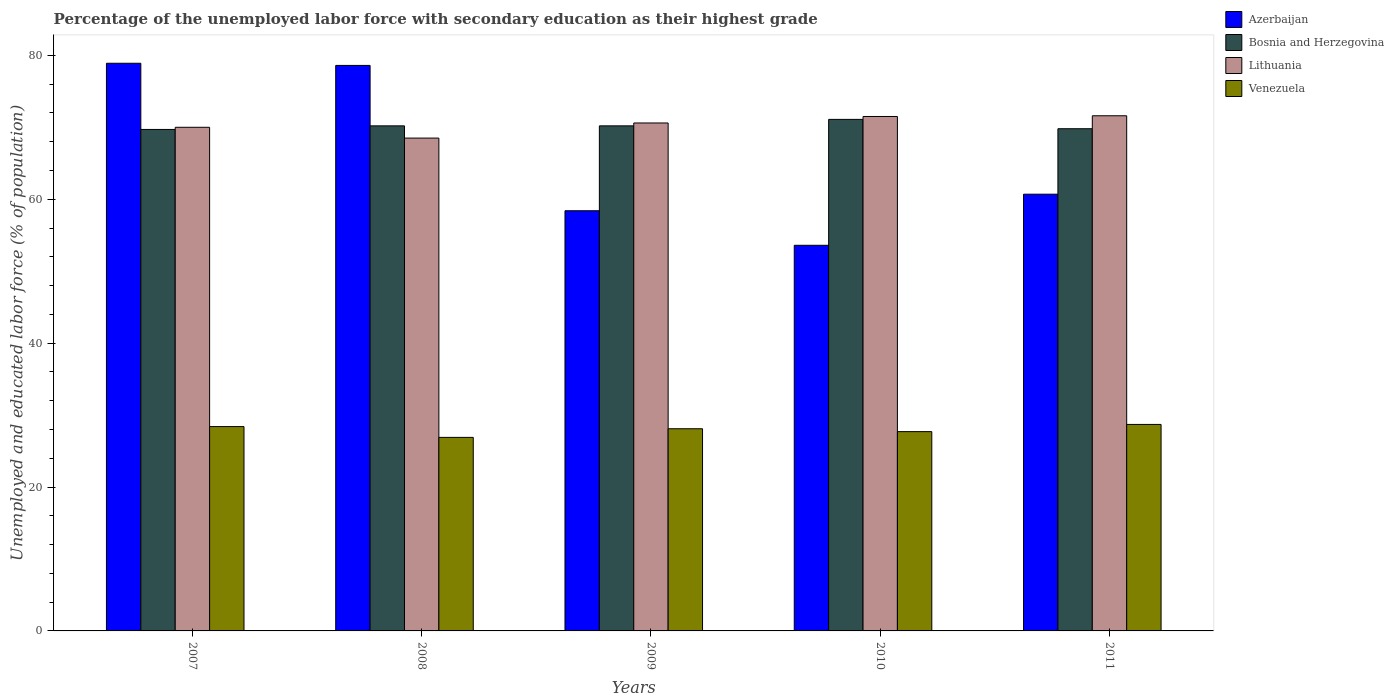How many groups of bars are there?
Provide a short and direct response. 5. Are the number of bars on each tick of the X-axis equal?
Ensure brevity in your answer.  Yes. How many bars are there on the 1st tick from the left?
Your answer should be compact. 4. How many bars are there on the 3rd tick from the right?
Your answer should be compact. 4. What is the label of the 3rd group of bars from the left?
Ensure brevity in your answer.  2009. What is the percentage of the unemployed labor force with secondary education in Azerbaijan in 2007?
Your answer should be very brief. 78.9. Across all years, what is the maximum percentage of the unemployed labor force with secondary education in Azerbaijan?
Provide a short and direct response. 78.9. Across all years, what is the minimum percentage of the unemployed labor force with secondary education in Azerbaijan?
Make the answer very short. 53.6. In which year was the percentage of the unemployed labor force with secondary education in Venezuela maximum?
Offer a terse response. 2011. In which year was the percentage of the unemployed labor force with secondary education in Azerbaijan minimum?
Offer a terse response. 2010. What is the total percentage of the unemployed labor force with secondary education in Azerbaijan in the graph?
Make the answer very short. 330.2. What is the difference between the percentage of the unemployed labor force with secondary education in Lithuania in 2010 and that in 2011?
Give a very brief answer. -0.1. What is the difference between the percentage of the unemployed labor force with secondary education in Lithuania in 2011 and the percentage of the unemployed labor force with secondary education in Venezuela in 2008?
Give a very brief answer. 44.7. What is the average percentage of the unemployed labor force with secondary education in Azerbaijan per year?
Your answer should be very brief. 66.04. In the year 2007, what is the difference between the percentage of the unemployed labor force with secondary education in Azerbaijan and percentage of the unemployed labor force with secondary education in Lithuania?
Your answer should be compact. 8.9. What is the ratio of the percentage of the unemployed labor force with secondary education in Azerbaijan in 2007 to that in 2011?
Provide a short and direct response. 1.3. Is the difference between the percentage of the unemployed labor force with secondary education in Azerbaijan in 2007 and 2010 greater than the difference between the percentage of the unemployed labor force with secondary education in Lithuania in 2007 and 2010?
Your answer should be very brief. Yes. What is the difference between the highest and the second highest percentage of the unemployed labor force with secondary education in Venezuela?
Offer a terse response. 0.3. What is the difference between the highest and the lowest percentage of the unemployed labor force with secondary education in Bosnia and Herzegovina?
Provide a short and direct response. 1.4. Is it the case that in every year, the sum of the percentage of the unemployed labor force with secondary education in Lithuania and percentage of the unemployed labor force with secondary education in Bosnia and Herzegovina is greater than the sum of percentage of the unemployed labor force with secondary education in Venezuela and percentage of the unemployed labor force with secondary education in Azerbaijan?
Give a very brief answer. No. What does the 4th bar from the left in 2010 represents?
Your answer should be compact. Venezuela. What does the 2nd bar from the right in 2009 represents?
Your answer should be very brief. Lithuania. Is it the case that in every year, the sum of the percentage of the unemployed labor force with secondary education in Bosnia and Herzegovina and percentage of the unemployed labor force with secondary education in Lithuania is greater than the percentage of the unemployed labor force with secondary education in Venezuela?
Give a very brief answer. Yes. Are the values on the major ticks of Y-axis written in scientific E-notation?
Your answer should be very brief. No. Does the graph contain any zero values?
Provide a succinct answer. No. Does the graph contain grids?
Your response must be concise. No. How many legend labels are there?
Your answer should be very brief. 4. How are the legend labels stacked?
Give a very brief answer. Vertical. What is the title of the graph?
Provide a short and direct response. Percentage of the unemployed labor force with secondary education as their highest grade. What is the label or title of the Y-axis?
Make the answer very short. Unemployed and educated labor force (% of population). What is the Unemployed and educated labor force (% of population) of Azerbaijan in 2007?
Your answer should be very brief. 78.9. What is the Unemployed and educated labor force (% of population) in Bosnia and Herzegovina in 2007?
Keep it short and to the point. 69.7. What is the Unemployed and educated labor force (% of population) in Venezuela in 2007?
Your response must be concise. 28.4. What is the Unemployed and educated labor force (% of population) of Azerbaijan in 2008?
Ensure brevity in your answer.  78.6. What is the Unemployed and educated labor force (% of population) of Bosnia and Herzegovina in 2008?
Your response must be concise. 70.2. What is the Unemployed and educated labor force (% of population) in Lithuania in 2008?
Your response must be concise. 68.5. What is the Unemployed and educated labor force (% of population) of Venezuela in 2008?
Ensure brevity in your answer.  26.9. What is the Unemployed and educated labor force (% of population) of Azerbaijan in 2009?
Offer a terse response. 58.4. What is the Unemployed and educated labor force (% of population) of Bosnia and Herzegovina in 2009?
Your answer should be compact. 70.2. What is the Unemployed and educated labor force (% of population) in Lithuania in 2009?
Make the answer very short. 70.6. What is the Unemployed and educated labor force (% of population) of Venezuela in 2009?
Make the answer very short. 28.1. What is the Unemployed and educated labor force (% of population) of Azerbaijan in 2010?
Provide a short and direct response. 53.6. What is the Unemployed and educated labor force (% of population) in Bosnia and Herzegovina in 2010?
Provide a succinct answer. 71.1. What is the Unemployed and educated labor force (% of population) of Lithuania in 2010?
Provide a succinct answer. 71.5. What is the Unemployed and educated labor force (% of population) of Venezuela in 2010?
Provide a succinct answer. 27.7. What is the Unemployed and educated labor force (% of population) of Azerbaijan in 2011?
Offer a very short reply. 60.7. What is the Unemployed and educated labor force (% of population) in Bosnia and Herzegovina in 2011?
Offer a terse response. 69.8. What is the Unemployed and educated labor force (% of population) in Lithuania in 2011?
Your response must be concise. 71.6. What is the Unemployed and educated labor force (% of population) in Venezuela in 2011?
Provide a succinct answer. 28.7. Across all years, what is the maximum Unemployed and educated labor force (% of population) in Azerbaijan?
Offer a very short reply. 78.9. Across all years, what is the maximum Unemployed and educated labor force (% of population) in Bosnia and Herzegovina?
Offer a terse response. 71.1. Across all years, what is the maximum Unemployed and educated labor force (% of population) of Lithuania?
Ensure brevity in your answer.  71.6. Across all years, what is the maximum Unemployed and educated labor force (% of population) in Venezuela?
Your response must be concise. 28.7. Across all years, what is the minimum Unemployed and educated labor force (% of population) of Azerbaijan?
Keep it short and to the point. 53.6. Across all years, what is the minimum Unemployed and educated labor force (% of population) of Bosnia and Herzegovina?
Your answer should be compact. 69.7. Across all years, what is the minimum Unemployed and educated labor force (% of population) in Lithuania?
Offer a very short reply. 68.5. Across all years, what is the minimum Unemployed and educated labor force (% of population) of Venezuela?
Your answer should be very brief. 26.9. What is the total Unemployed and educated labor force (% of population) in Azerbaijan in the graph?
Keep it short and to the point. 330.2. What is the total Unemployed and educated labor force (% of population) in Bosnia and Herzegovina in the graph?
Keep it short and to the point. 351. What is the total Unemployed and educated labor force (% of population) of Lithuania in the graph?
Ensure brevity in your answer.  352.2. What is the total Unemployed and educated labor force (% of population) of Venezuela in the graph?
Keep it short and to the point. 139.8. What is the difference between the Unemployed and educated labor force (% of population) of Azerbaijan in 2007 and that in 2008?
Give a very brief answer. 0.3. What is the difference between the Unemployed and educated labor force (% of population) of Lithuania in 2007 and that in 2008?
Give a very brief answer. 1.5. What is the difference between the Unemployed and educated labor force (% of population) of Lithuania in 2007 and that in 2009?
Provide a short and direct response. -0.6. What is the difference between the Unemployed and educated labor force (% of population) of Azerbaijan in 2007 and that in 2010?
Your answer should be very brief. 25.3. What is the difference between the Unemployed and educated labor force (% of population) in Lithuania in 2007 and that in 2010?
Offer a terse response. -1.5. What is the difference between the Unemployed and educated labor force (% of population) in Venezuela in 2007 and that in 2010?
Offer a terse response. 0.7. What is the difference between the Unemployed and educated labor force (% of population) of Azerbaijan in 2007 and that in 2011?
Make the answer very short. 18.2. What is the difference between the Unemployed and educated labor force (% of population) in Bosnia and Herzegovina in 2007 and that in 2011?
Give a very brief answer. -0.1. What is the difference between the Unemployed and educated labor force (% of population) of Lithuania in 2007 and that in 2011?
Provide a short and direct response. -1.6. What is the difference between the Unemployed and educated labor force (% of population) of Venezuela in 2007 and that in 2011?
Keep it short and to the point. -0.3. What is the difference between the Unemployed and educated labor force (% of population) in Azerbaijan in 2008 and that in 2009?
Your answer should be compact. 20.2. What is the difference between the Unemployed and educated labor force (% of population) in Venezuela in 2008 and that in 2009?
Make the answer very short. -1.2. What is the difference between the Unemployed and educated labor force (% of population) in Bosnia and Herzegovina in 2008 and that in 2010?
Provide a short and direct response. -0.9. What is the difference between the Unemployed and educated labor force (% of population) of Bosnia and Herzegovina in 2008 and that in 2011?
Keep it short and to the point. 0.4. What is the difference between the Unemployed and educated labor force (% of population) in Lithuania in 2008 and that in 2011?
Keep it short and to the point. -3.1. What is the difference between the Unemployed and educated labor force (% of population) of Venezuela in 2008 and that in 2011?
Ensure brevity in your answer.  -1.8. What is the difference between the Unemployed and educated labor force (% of population) of Azerbaijan in 2009 and that in 2010?
Offer a terse response. 4.8. What is the difference between the Unemployed and educated labor force (% of population) in Bosnia and Herzegovina in 2009 and that in 2010?
Offer a very short reply. -0.9. What is the difference between the Unemployed and educated labor force (% of population) in Venezuela in 2009 and that in 2010?
Ensure brevity in your answer.  0.4. What is the difference between the Unemployed and educated labor force (% of population) in Lithuania in 2009 and that in 2011?
Your answer should be compact. -1. What is the difference between the Unemployed and educated labor force (% of population) in Venezuela in 2009 and that in 2011?
Your response must be concise. -0.6. What is the difference between the Unemployed and educated labor force (% of population) of Azerbaijan in 2007 and the Unemployed and educated labor force (% of population) of Venezuela in 2008?
Your answer should be compact. 52. What is the difference between the Unemployed and educated labor force (% of population) in Bosnia and Herzegovina in 2007 and the Unemployed and educated labor force (% of population) in Lithuania in 2008?
Your answer should be very brief. 1.2. What is the difference between the Unemployed and educated labor force (% of population) in Bosnia and Herzegovina in 2007 and the Unemployed and educated labor force (% of population) in Venezuela in 2008?
Your answer should be compact. 42.8. What is the difference between the Unemployed and educated labor force (% of population) of Lithuania in 2007 and the Unemployed and educated labor force (% of population) of Venezuela in 2008?
Offer a very short reply. 43.1. What is the difference between the Unemployed and educated labor force (% of population) of Azerbaijan in 2007 and the Unemployed and educated labor force (% of population) of Venezuela in 2009?
Your answer should be very brief. 50.8. What is the difference between the Unemployed and educated labor force (% of population) in Bosnia and Herzegovina in 2007 and the Unemployed and educated labor force (% of population) in Venezuela in 2009?
Provide a succinct answer. 41.6. What is the difference between the Unemployed and educated labor force (% of population) of Lithuania in 2007 and the Unemployed and educated labor force (% of population) of Venezuela in 2009?
Your answer should be very brief. 41.9. What is the difference between the Unemployed and educated labor force (% of population) in Azerbaijan in 2007 and the Unemployed and educated labor force (% of population) in Bosnia and Herzegovina in 2010?
Make the answer very short. 7.8. What is the difference between the Unemployed and educated labor force (% of population) of Azerbaijan in 2007 and the Unemployed and educated labor force (% of population) of Lithuania in 2010?
Give a very brief answer. 7.4. What is the difference between the Unemployed and educated labor force (% of population) in Azerbaijan in 2007 and the Unemployed and educated labor force (% of population) in Venezuela in 2010?
Offer a terse response. 51.2. What is the difference between the Unemployed and educated labor force (% of population) of Bosnia and Herzegovina in 2007 and the Unemployed and educated labor force (% of population) of Venezuela in 2010?
Your answer should be very brief. 42. What is the difference between the Unemployed and educated labor force (% of population) in Lithuania in 2007 and the Unemployed and educated labor force (% of population) in Venezuela in 2010?
Make the answer very short. 42.3. What is the difference between the Unemployed and educated labor force (% of population) of Azerbaijan in 2007 and the Unemployed and educated labor force (% of population) of Bosnia and Herzegovina in 2011?
Offer a very short reply. 9.1. What is the difference between the Unemployed and educated labor force (% of population) in Azerbaijan in 2007 and the Unemployed and educated labor force (% of population) in Venezuela in 2011?
Offer a terse response. 50.2. What is the difference between the Unemployed and educated labor force (% of population) in Lithuania in 2007 and the Unemployed and educated labor force (% of population) in Venezuela in 2011?
Give a very brief answer. 41.3. What is the difference between the Unemployed and educated labor force (% of population) in Azerbaijan in 2008 and the Unemployed and educated labor force (% of population) in Venezuela in 2009?
Provide a succinct answer. 50.5. What is the difference between the Unemployed and educated labor force (% of population) in Bosnia and Herzegovina in 2008 and the Unemployed and educated labor force (% of population) in Venezuela in 2009?
Offer a very short reply. 42.1. What is the difference between the Unemployed and educated labor force (% of population) in Lithuania in 2008 and the Unemployed and educated labor force (% of population) in Venezuela in 2009?
Your response must be concise. 40.4. What is the difference between the Unemployed and educated labor force (% of population) of Azerbaijan in 2008 and the Unemployed and educated labor force (% of population) of Lithuania in 2010?
Offer a very short reply. 7.1. What is the difference between the Unemployed and educated labor force (% of population) of Azerbaijan in 2008 and the Unemployed and educated labor force (% of population) of Venezuela in 2010?
Ensure brevity in your answer.  50.9. What is the difference between the Unemployed and educated labor force (% of population) in Bosnia and Herzegovina in 2008 and the Unemployed and educated labor force (% of population) in Venezuela in 2010?
Give a very brief answer. 42.5. What is the difference between the Unemployed and educated labor force (% of population) in Lithuania in 2008 and the Unemployed and educated labor force (% of population) in Venezuela in 2010?
Make the answer very short. 40.8. What is the difference between the Unemployed and educated labor force (% of population) in Azerbaijan in 2008 and the Unemployed and educated labor force (% of population) in Venezuela in 2011?
Provide a short and direct response. 49.9. What is the difference between the Unemployed and educated labor force (% of population) of Bosnia and Herzegovina in 2008 and the Unemployed and educated labor force (% of population) of Venezuela in 2011?
Offer a terse response. 41.5. What is the difference between the Unemployed and educated labor force (% of population) in Lithuania in 2008 and the Unemployed and educated labor force (% of population) in Venezuela in 2011?
Make the answer very short. 39.8. What is the difference between the Unemployed and educated labor force (% of population) in Azerbaijan in 2009 and the Unemployed and educated labor force (% of population) in Bosnia and Herzegovina in 2010?
Your answer should be compact. -12.7. What is the difference between the Unemployed and educated labor force (% of population) in Azerbaijan in 2009 and the Unemployed and educated labor force (% of population) in Lithuania in 2010?
Offer a terse response. -13.1. What is the difference between the Unemployed and educated labor force (% of population) in Azerbaijan in 2009 and the Unemployed and educated labor force (% of population) in Venezuela in 2010?
Your answer should be compact. 30.7. What is the difference between the Unemployed and educated labor force (% of population) in Bosnia and Herzegovina in 2009 and the Unemployed and educated labor force (% of population) in Lithuania in 2010?
Make the answer very short. -1.3. What is the difference between the Unemployed and educated labor force (% of population) in Bosnia and Herzegovina in 2009 and the Unemployed and educated labor force (% of population) in Venezuela in 2010?
Your answer should be very brief. 42.5. What is the difference between the Unemployed and educated labor force (% of population) of Lithuania in 2009 and the Unemployed and educated labor force (% of population) of Venezuela in 2010?
Your answer should be compact. 42.9. What is the difference between the Unemployed and educated labor force (% of population) in Azerbaijan in 2009 and the Unemployed and educated labor force (% of population) in Bosnia and Herzegovina in 2011?
Your answer should be very brief. -11.4. What is the difference between the Unemployed and educated labor force (% of population) in Azerbaijan in 2009 and the Unemployed and educated labor force (% of population) in Venezuela in 2011?
Offer a very short reply. 29.7. What is the difference between the Unemployed and educated labor force (% of population) of Bosnia and Herzegovina in 2009 and the Unemployed and educated labor force (% of population) of Venezuela in 2011?
Provide a succinct answer. 41.5. What is the difference between the Unemployed and educated labor force (% of population) of Lithuania in 2009 and the Unemployed and educated labor force (% of population) of Venezuela in 2011?
Your answer should be very brief. 41.9. What is the difference between the Unemployed and educated labor force (% of population) of Azerbaijan in 2010 and the Unemployed and educated labor force (% of population) of Bosnia and Herzegovina in 2011?
Ensure brevity in your answer.  -16.2. What is the difference between the Unemployed and educated labor force (% of population) in Azerbaijan in 2010 and the Unemployed and educated labor force (% of population) in Venezuela in 2011?
Offer a very short reply. 24.9. What is the difference between the Unemployed and educated labor force (% of population) of Bosnia and Herzegovina in 2010 and the Unemployed and educated labor force (% of population) of Venezuela in 2011?
Your answer should be very brief. 42.4. What is the difference between the Unemployed and educated labor force (% of population) of Lithuania in 2010 and the Unemployed and educated labor force (% of population) of Venezuela in 2011?
Give a very brief answer. 42.8. What is the average Unemployed and educated labor force (% of population) of Azerbaijan per year?
Your answer should be compact. 66.04. What is the average Unemployed and educated labor force (% of population) in Bosnia and Herzegovina per year?
Provide a succinct answer. 70.2. What is the average Unemployed and educated labor force (% of population) in Lithuania per year?
Ensure brevity in your answer.  70.44. What is the average Unemployed and educated labor force (% of population) in Venezuela per year?
Offer a very short reply. 27.96. In the year 2007, what is the difference between the Unemployed and educated labor force (% of population) of Azerbaijan and Unemployed and educated labor force (% of population) of Bosnia and Herzegovina?
Make the answer very short. 9.2. In the year 2007, what is the difference between the Unemployed and educated labor force (% of population) of Azerbaijan and Unemployed and educated labor force (% of population) of Lithuania?
Your answer should be very brief. 8.9. In the year 2007, what is the difference between the Unemployed and educated labor force (% of population) of Azerbaijan and Unemployed and educated labor force (% of population) of Venezuela?
Ensure brevity in your answer.  50.5. In the year 2007, what is the difference between the Unemployed and educated labor force (% of population) in Bosnia and Herzegovina and Unemployed and educated labor force (% of population) in Lithuania?
Provide a succinct answer. -0.3. In the year 2007, what is the difference between the Unemployed and educated labor force (% of population) in Bosnia and Herzegovina and Unemployed and educated labor force (% of population) in Venezuela?
Make the answer very short. 41.3. In the year 2007, what is the difference between the Unemployed and educated labor force (% of population) of Lithuania and Unemployed and educated labor force (% of population) of Venezuela?
Offer a terse response. 41.6. In the year 2008, what is the difference between the Unemployed and educated labor force (% of population) in Azerbaijan and Unemployed and educated labor force (% of population) in Bosnia and Herzegovina?
Offer a very short reply. 8.4. In the year 2008, what is the difference between the Unemployed and educated labor force (% of population) of Azerbaijan and Unemployed and educated labor force (% of population) of Venezuela?
Keep it short and to the point. 51.7. In the year 2008, what is the difference between the Unemployed and educated labor force (% of population) in Bosnia and Herzegovina and Unemployed and educated labor force (% of population) in Venezuela?
Your response must be concise. 43.3. In the year 2008, what is the difference between the Unemployed and educated labor force (% of population) of Lithuania and Unemployed and educated labor force (% of population) of Venezuela?
Your answer should be very brief. 41.6. In the year 2009, what is the difference between the Unemployed and educated labor force (% of population) of Azerbaijan and Unemployed and educated labor force (% of population) of Venezuela?
Provide a succinct answer. 30.3. In the year 2009, what is the difference between the Unemployed and educated labor force (% of population) in Bosnia and Herzegovina and Unemployed and educated labor force (% of population) in Venezuela?
Offer a very short reply. 42.1. In the year 2009, what is the difference between the Unemployed and educated labor force (% of population) of Lithuania and Unemployed and educated labor force (% of population) of Venezuela?
Keep it short and to the point. 42.5. In the year 2010, what is the difference between the Unemployed and educated labor force (% of population) in Azerbaijan and Unemployed and educated labor force (% of population) in Bosnia and Herzegovina?
Provide a short and direct response. -17.5. In the year 2010, what is the difference between the Unemployed and educated labor force (% of population) of Azerbaijan and Unemployed and educated labor force (% of population) of Lithuania?
Offer a very short reply. -17.9. In the year 2010, what is the difference between the Unemployed and educated labor force (% of population) of Azerbaijan and Unemployed and educated labor force (% of population) of Venezuela?
Your response must be concise. 25.9. In the year 2010, what is the difference between the Unemployed and educated labor force (% of population) of Bosnia and Herzegovina and Unemployed and educated labor force (% of population) of Venezuela?
Make the answer very short. 43.4. In the year 2010, what is the difference between the Unemployed and educated labor force (% of population) in Lithuania and Unemployed and educated labor force (% of population) in Venezuela?
Your response must be concise. 43.8. In the year 2011, what is the difference between the Unemployed and educated labor force (% of population) of Azerbaijan and Unemployed and educated labor force (% of population) of Bosnia and Herzegovina?
Keep it short and to the point. -9.1. In the year 2011, what is the difference between the Unemployed and educated labor force (% of population) in Azerbaijan and Unemployed and educated labor force (% of population) in Lithuania?
Keep it short and to the point. -10.9. In the year 2011, what is the difference between the Unemployed and educated labor force (% of population) in Azerbaijan and Unemployed and educated labor force (% of population) in Venezuela?
Provide a succinct answer. 32. In the year 2011, what is the difference between the Unemployed and educated labor force (% of population) in Bosnia and Herzegovina and Unemployed and educated labor force (% of population) in Lithuania?
Keep it short and to the point. -1.8. In the year 2011, what is the difference between the Unemployed and educated labor force (% of population) in Bosnia and Herzegovina and Unemployed and educated labor force (% of population) in Venezuela?
Provide a succinct answer. 41.1. In the year 2011, what is the difference between the Unemployed and educated labor force (% of population) in Lithuania and Unemployed and educated labor force (% of population) in Venezuela?
Keep it short and to the point. 42.9. What is the ratio of the Unemployed and educated labor force (% of population) of Bosnia and Herzegovina in 2007 to that in 2008?
Offer a terse response. 0.99. What is the ratio of the Unemployed and educated labor force (% of population) in Lithuania in 2007 to that in 2008?
Your answer should be compact. 1.02. What is the ratio of the Unemployed and educated labor force (% of population) of Venezuela in 2007 to that in 2008?
Ensure brevity in your answer.  1.06. What is the ratio of the Unemployed and educated labor force (% of population) of Azerbaijan in 2007 to that in 2009?
Keep it short and to the point. 1.35. What is the ratio of the Unemployed and educated labor force (% of population) of Lithuania in 2007 to that in 2009?
Keep it short and to the point. 0.99. What is the ratio of the Unemployed and educated labor force (% of population) in Venezuela in 2007 to that in 2009?
Your answer should be compact. 1.01. What is the ratio of the Unemployed and educated labor force (% of population) of Azerbaijan in 2007 to that in 2010?
Your response must be concise. 1.47. What is the ratio of the Unemployed and educated labor force (% of population) of Bosnia and Herzegovina in 2007 to that in 2010?
Your answer should be compact. 0.98. What is the ratio of the Unemployed and educated labor force (% of population) of Lithuania in 2007 to that in 2010?
Ensure brevity in your answer.  0.98. What is the ratio of the Unemployed and educated labor force (% of population) in Venezuela in 2007 to that in 2010?
Offer a terse response. 1.03. What is the ratio of the Unemployed and educated labor force (% of population) of Azerbaijan in 2007 to that in 2011?
Keep it short and to the point. 1.3. What is the ratio of the Unemployed and educated labor force (% of population) of Bosnia and Herzegovina in 2007 to that in 2011?
Offer a terse response. 1. What is the ratio of the Unemployed and educated labor force (% of population) of Lithuania in 2007 to that in 2011?
Provide a short and direct response. 0.98. What is the ratio of the Unemployed and educated labor force (% of population) of Azerbaijan in 2008 to that in 2009?
Make the answer very short. 1.35. What is the ratio of the Unemployed and educated labor force (% of population) in Lithuania in 2008 to that in 2009?
Your answer should be very brief. 0.97. What is the ratio of the Unemployed and educated labor force (% of population) of Venezuela in 2008 to that in 2009?
Ensure brevity in your answer.  0.96. What is the ratio of the Unemployed and educated labor force (% of population) in Azerbaijan in 2008 to that in 2010?
Your response must be concise. 1.47. What is the ratio of the Unemployed and educated labor force (% of population) of Bosnia and Herzegovina in 2008 to that in 2010?
Offer a very short reply. 0.99. What is the ratio of the Unemployed and educated labor force (% of population) in Lithuania in 2008 to that in 2010?
Your response must be concise. 0.96. What is the ratio of the Unemployed and educated labor force (% of population) of Venezuela in 2008 to that in 2010?
Give a very brief answer. 0.97. What is the ratio of the Unemployed and educated labor force (% of population) in Azerbaijan in 2008 to that in 2011?
Your answer should be very brief. 1.29. What is the ratio of the Unemployed and educated labor force (% of population) in Lithuania in 2008 to that in 2011?
Your answer should be compact. 0.96. What is the ratio of the Unemployed and educated labor force (% of population) in Venezuela in 2008 to that in 2011?
Make the answer very short. 0.94. What is the ratio of the Unemployed and educated labor force (% of population) of Azerbaijan in 2009 to that in 2010?
Provide a short and direct response. 1.09. What is the ratio of the Unemployed and educated labor force (% of population) in Bosnia and Herzegovina in 2009 to that in 2010?
Ensure brevity in your answer.  0.99. What is the ratio of the Unemployed and educated labor force (% of population) in Lithuania in 2009 to that in 2010?
Keep it short and to the point. 0.99. What is the ratio of the Unemployed and educated labor force (% of population) of Venezuela in 2009 to that in 2010?
Provide a short and direct response. 1.01. What is the ratio of the Unemployed and educated labor force (% of population) of Azerbaijan in 2009 to that in 2011?
Ensure brevity in your answer.  0.96. What is the ratio of the Unemployed and educated labor force (% of population) of Lithuania in 2009 to that in 2011?
Keep it short and to the point. 0.99. What is the ratio of the Unemployed and educated labor force (% of population) in Venezuela in 2009 to that in 2011?
Offer a very short reply. 0.98. What is the ratio of the Unemployed and educated labor force (% of population) in Azerbaijan in 2010 to that in 2011?
Keep it short and to the point. 0.88. What is the ratio of the Unemployed and educated labor force (% of population) of Bosnia and Herzegovina in 2010 to that in 2011?
Ensure brevity in your answer.  1.02. What is the ratio of the Unemployed and educated labor force (% of population) in Lithuania in 2010 to that in 2011?
Provide a succinct answer. 1. What is the ratio of the Unemployed and educated labor force (% of population) of Venezuela in 2010 to that in 2011?
Ensure brevity in your answer.  0.97. What is the difference between the highest and the second highest Unemployed and educated labor force (% of population) of Azerbaijan?
Your answer should be compact. 0.3. What is the difference between the highest and the second highest Unemployed and educated labor force (% of population) in Lithuania?
Your answer should be compact. 0.1. What is the difference between the highest and the lowest Unemployed and educated labor force (% of population) of Azerbaijan?
Give a very brief answer. 25.3. 